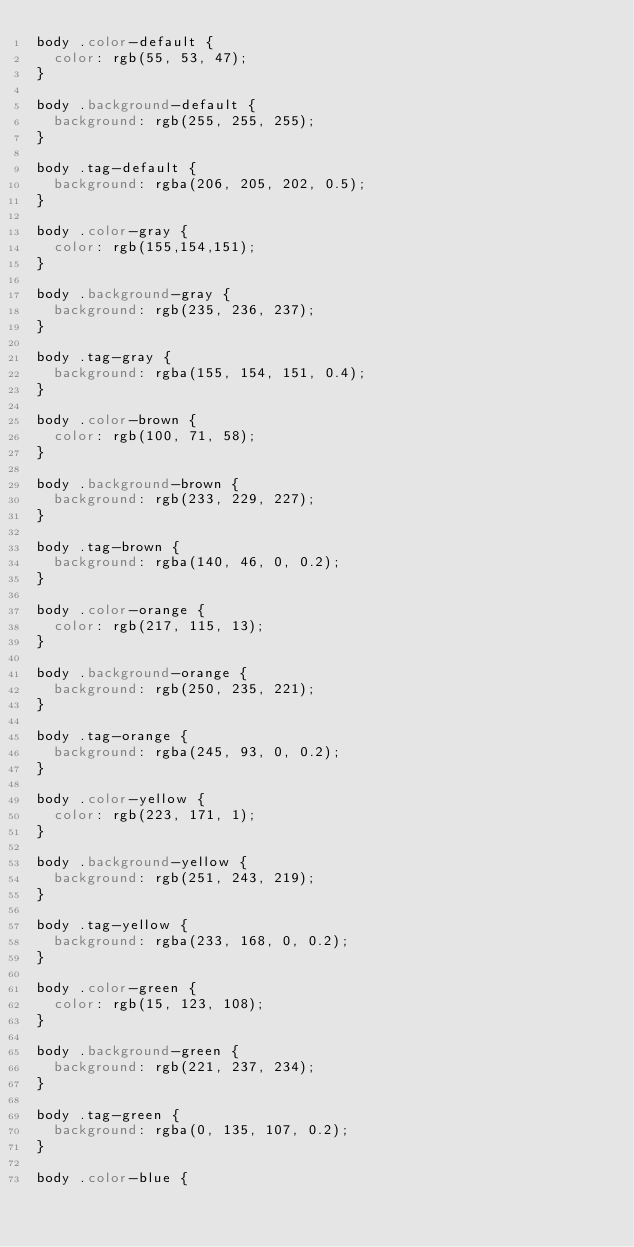Convert code to text. <code><loc_0><loc_0><loc_500><loc_500><_CSS_>body .color-default {
  color: rgb(55, 53, 47);
}

body .background-default {
  background: rgb(255, 255, 255);
}

body .tag-default {
  background: rgba(206, 205, 202, 0.5);
}

body .color-gray {
  color: rgb(155,154,151);
}

body .background-gray {
  background: rgb(235, 236, 237);
}

body .tag-gray {
  background: rgba(155, 154, 151, 0.4);
}

body .color-brown {
  color: rgb(100, 71, 58);
}

body .background-brown {
  background: rgb(233, 229, 227);
}

body .tag-brown {
  background: rgba(140, 46, 0, 0.2);
}

body .color-orange {
  color: rgb(217, 115, 13);
}

body .background-orange {
  background: rgb(250, 235, 221);
}

body .tag-orange {
  background: rgba(245, 93, 0, 0.2);
}

body .color-yellow {
  color: rgb(223, 171, 1);
}

body .background-yellow {
  background: rgb(251, 243, 219);
}

body .tag-yellow {
  background: rgba(233, 168, 0, 0.2);
}

body .color-green {
  color: rgb(15, 123, 108);
}

body .background-green {
  background: rgb(221, 237, 234);
}

body .tag-green {
  background: rgba(0, 135, 107, 0.2);
}

body .color-blue {</code> 